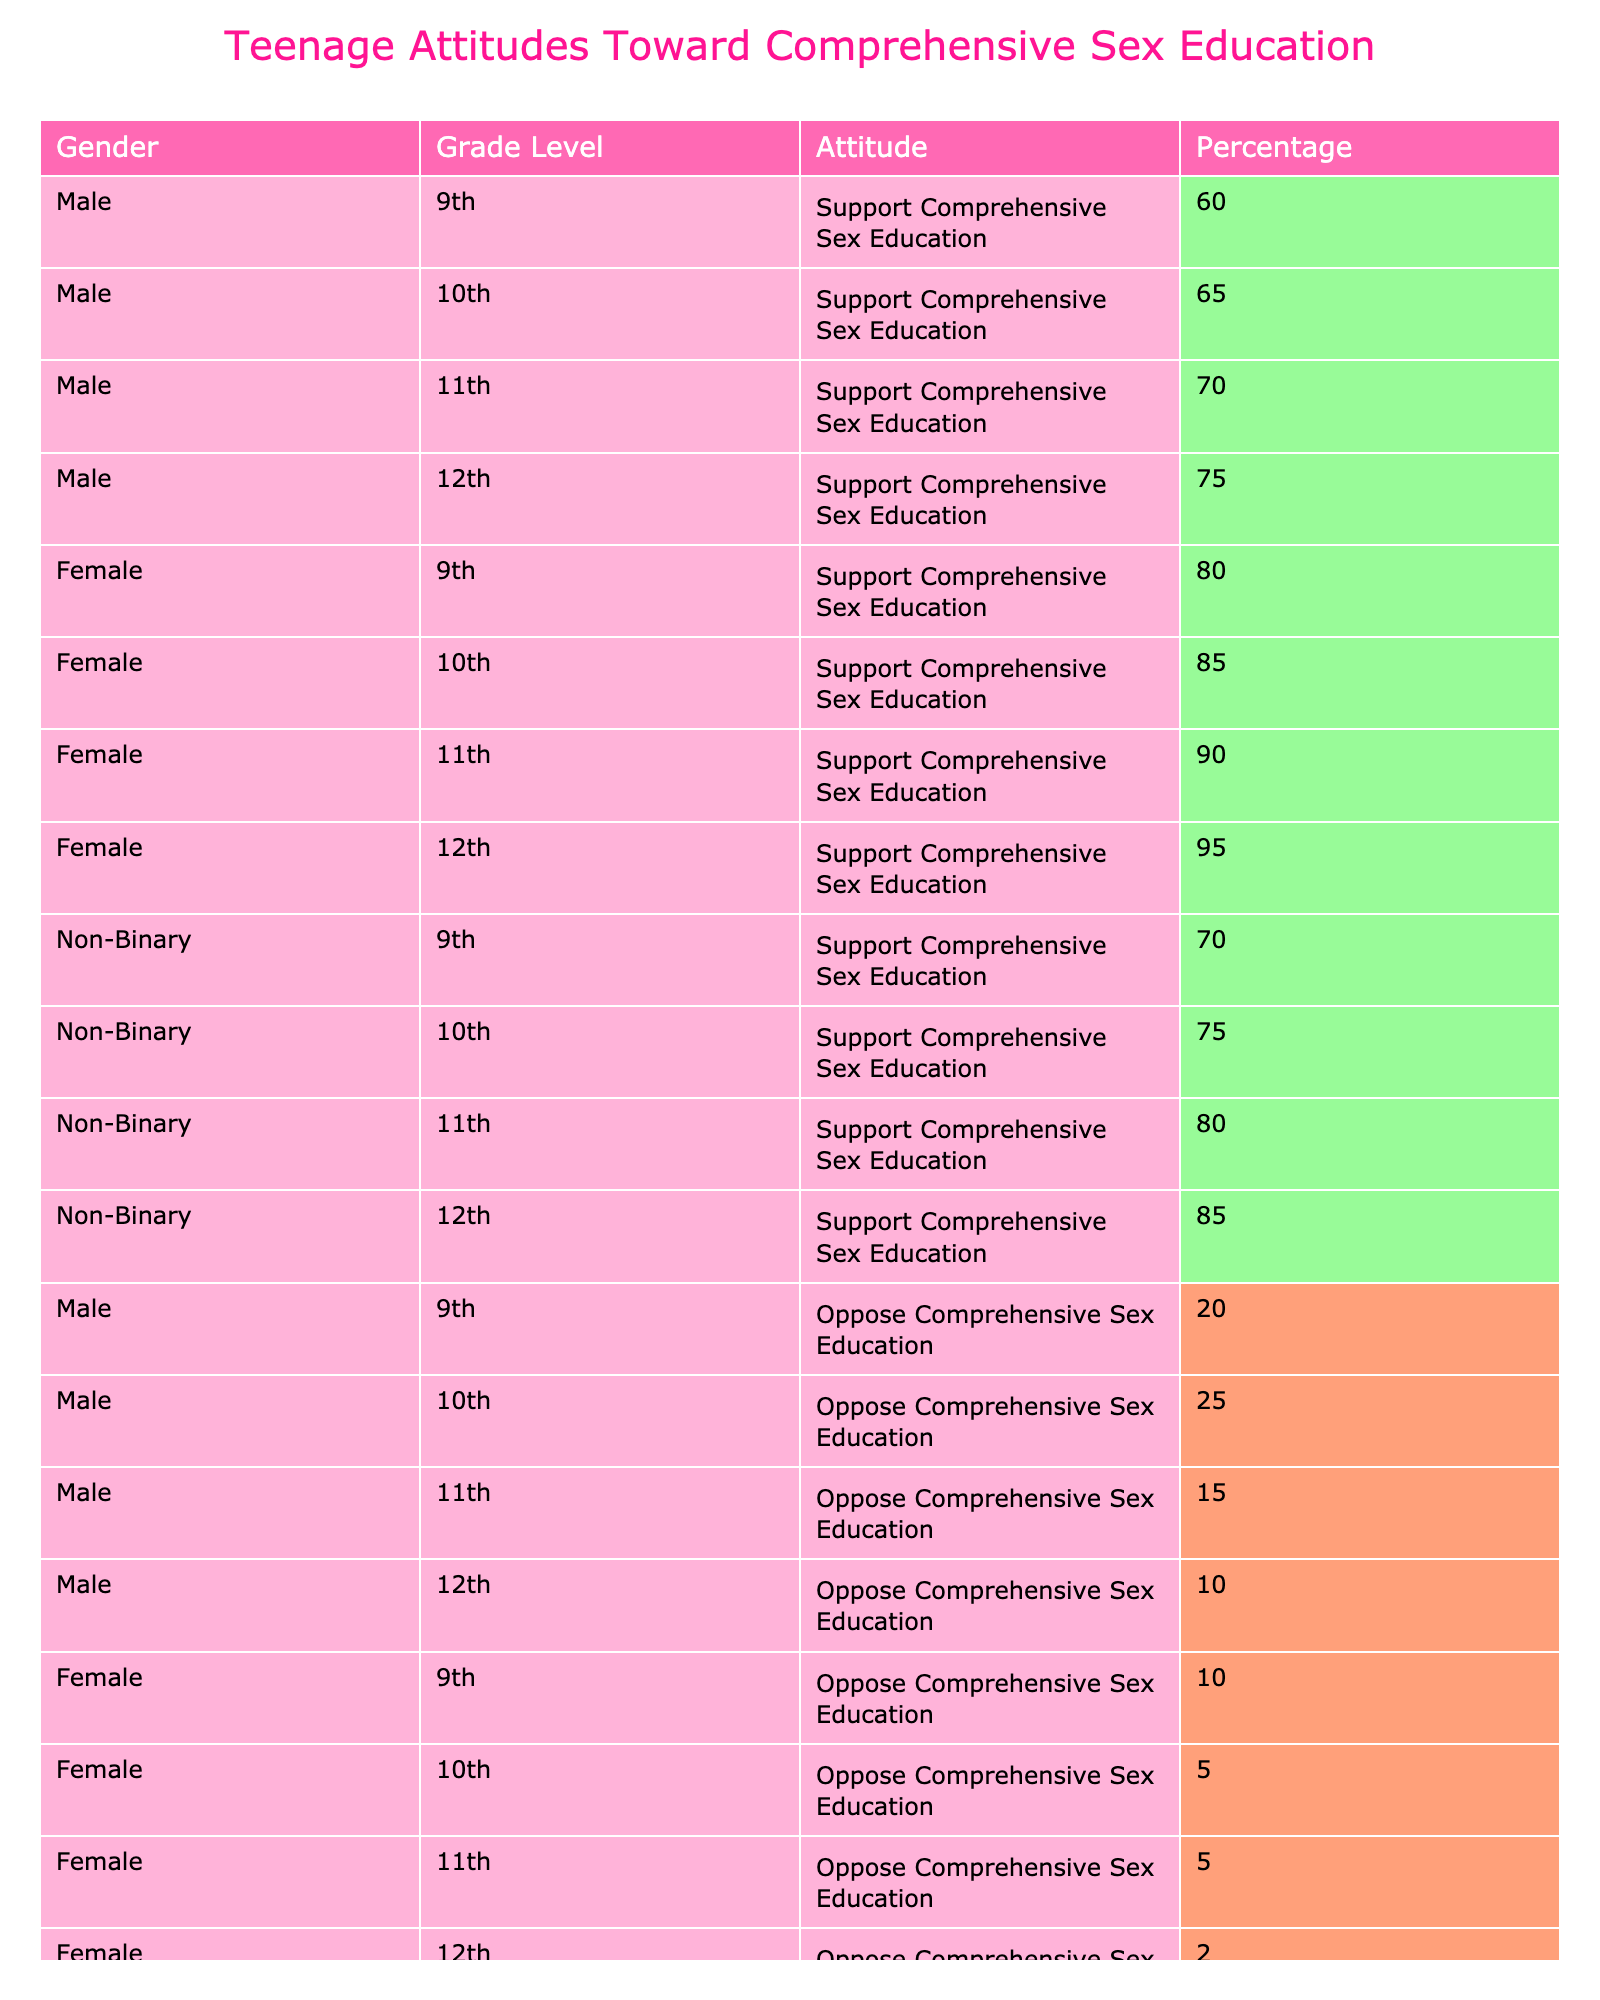What percentage of 10th-grade females support comprehensive sex education? From the table, I look for the row corresponding to females in the 10th grade, and I see that 85% support comprehensive sex education.
Answer: 85% Which gender shows the highest level of support for comprehensive sex education among 12th graders? In the table, I compare the percentages for 12th-grade students by gender. Males have 75%, females have 95%, and non-binary individuals have 85%. Females show the highest support at 95%.
Answer: Females What is the difference in support for comprehensive sex education between 11th-grade males and females? For males, the support percentage is 70%, and for females, it is 90%. The difference is 90 - 70 = 20%.
Answer: 20% Are more non-binary students unsure about comprehensive sex education than male students? I check the "Unsure" percentage for non-binary and male students in all grades. Non-binary students have percentages of 15%, 15%, 10%, and 10%, resulting in an average of 12.5%. Male students have percentages of 20%, 10%, 15%, and 15%, resulting in an average of 15%. Since 12.5% < 15%, the answer is no.
Answer: No What is the combined support percentage for comprehensive sex education for all 9th-grade students? I calculate the total support for 9th-grade students across all genders. Males have 60%, females have 80%, and non-binary have 70%. The total is 60 + 80 + 70 = 210%. With three groups, the average support is 210/3 = 70%.
Answer: 70% 